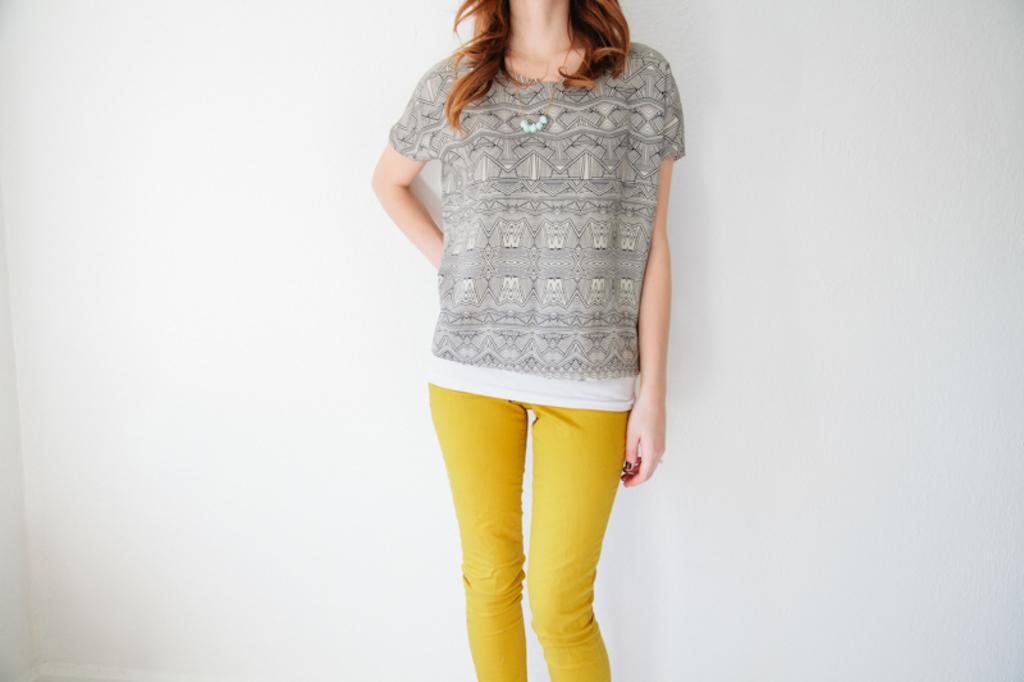In one or two sentences, can you explain what this image depicts? This is the picture of a top and a yellow pant to the lady. 